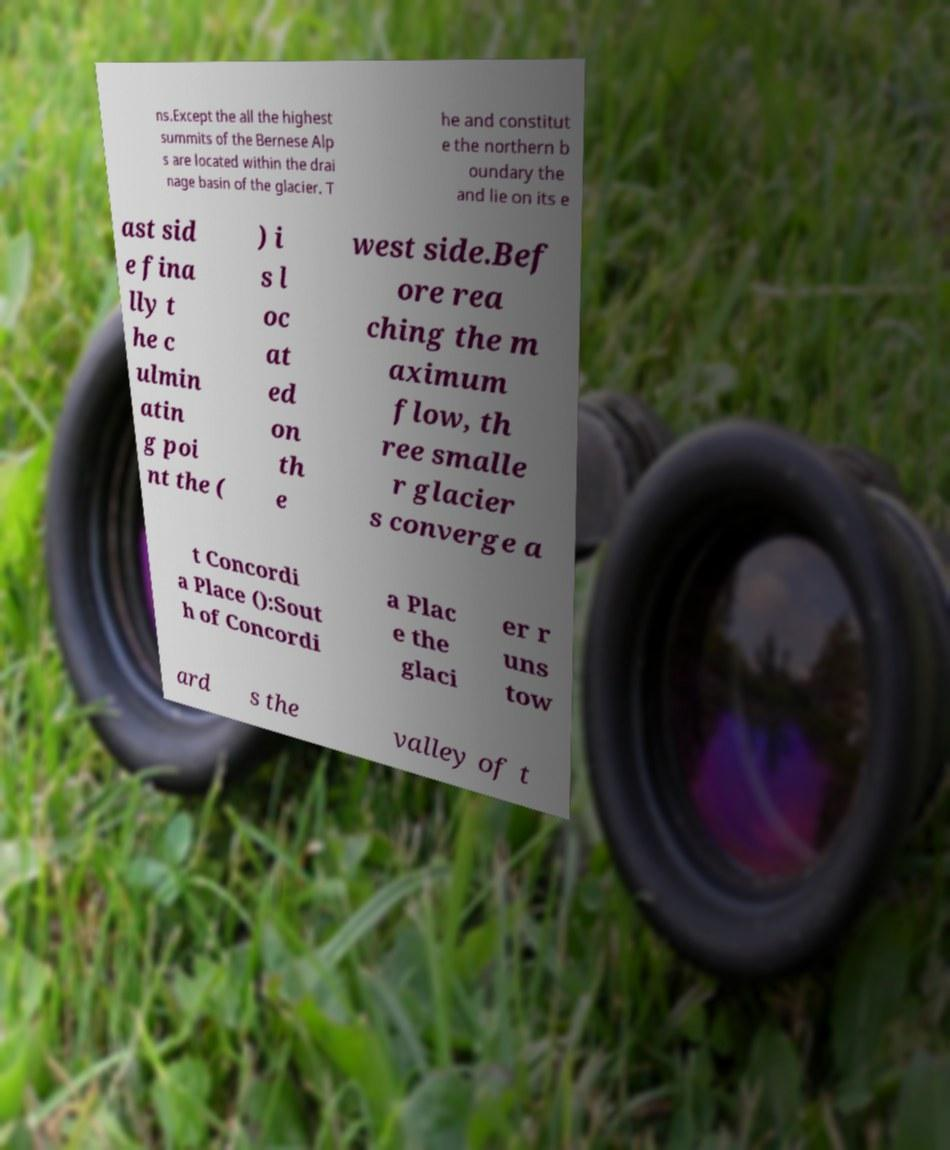Can you accurately transcribe the text from the provided image for me? ns.Except the all the highest summits of the Bernese Alp s are located within the drai nage basin of the glacier. T he and constitut e the northern b oundary the and lie on its e ast sid e fina lly t he c ulmin atin g poi nt the ( ) i s l oc at ed on th e west side.Bef ore rea ching the m aximum flow, th ree smalle r glacier s converge a t Concordi a Place ():Sout h of Concordi a Plac e the glaci er r uns tow ard s the valley of t 